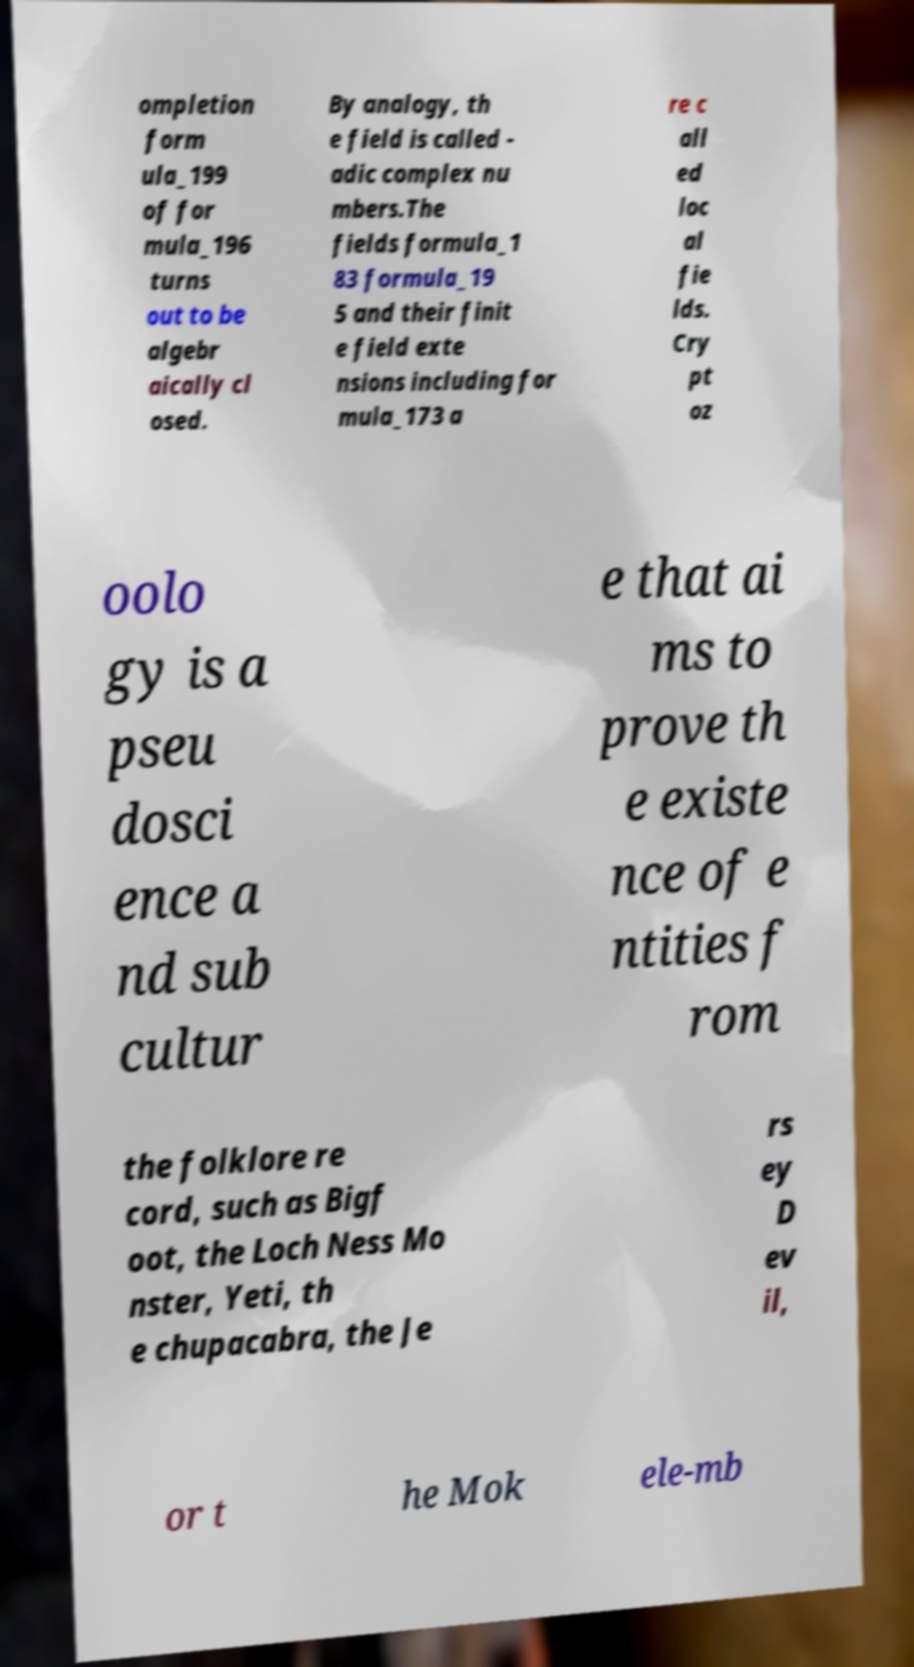I need the written content from this picture converted into text. Can you do that? ompletion form ula_199 of for mula_196 turns out to be algebr aically cl osed. By analogy, th e field is called - adic complex nu mbers.The fields formula_1 83 formula_19 5 and their finit e field exte nsions including for mula_173 a re c all ed loc al fie lds. Cry pt oz oolo gy is a pseu dosci ence a nd sub cultur e that ai ms to prove th e existe nce of e ntities f rom the folklore re cord, such as Bigf oot, the Loch Ness Mo nster, Yeti, th e chupacabra, the Je rs ey D ev il, or t he Mok ele-mb 